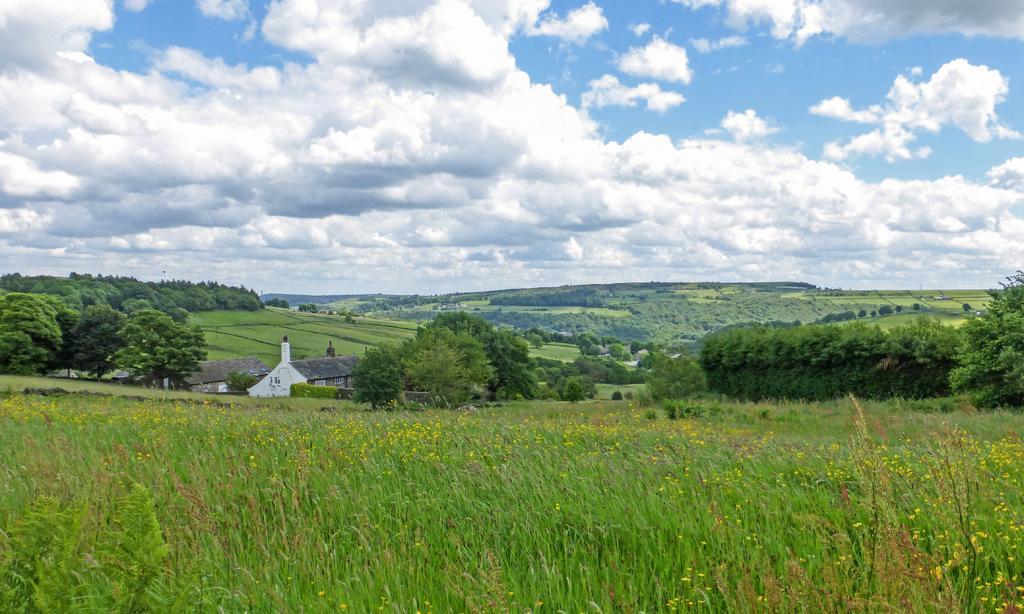Please provide a concise description of this image. In this image we can see the houses and plants with flowers. And there are trees, grass and cloudy sky in the background. 